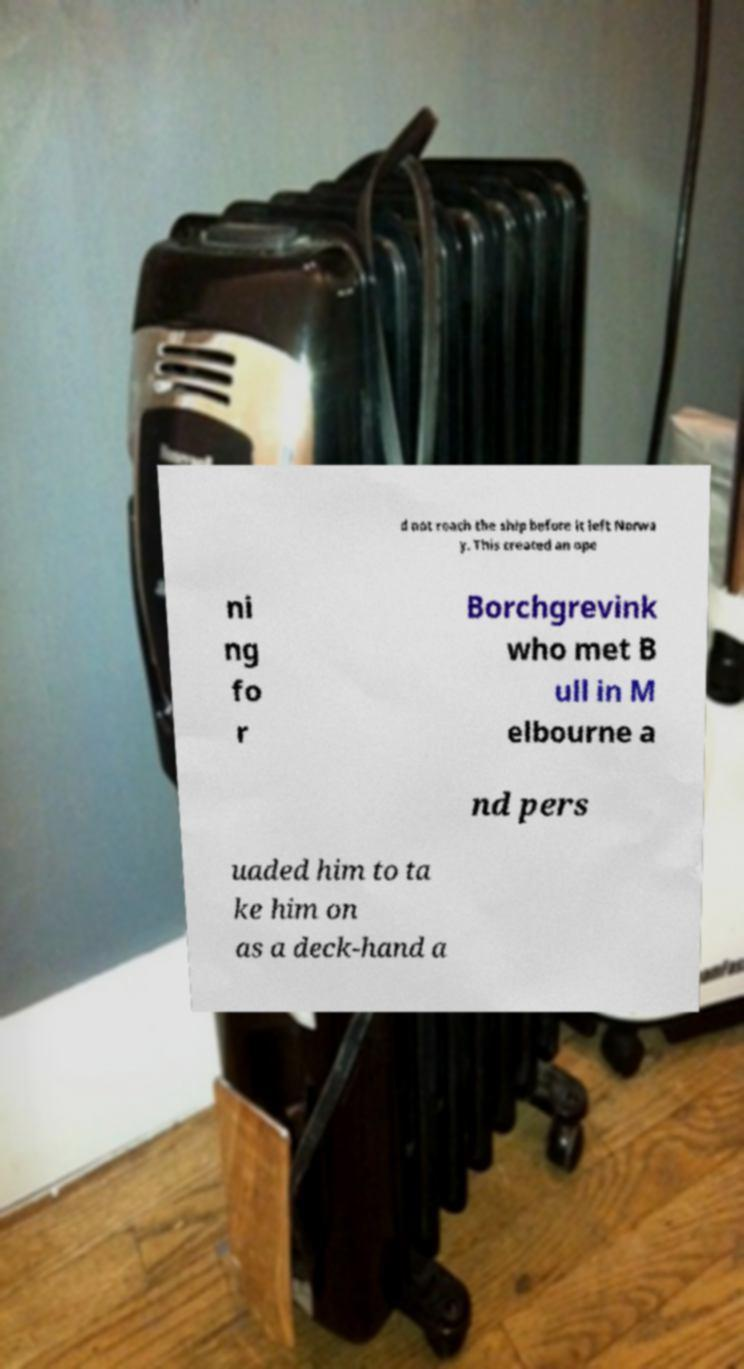I need the written content from this picture converted into text. Can you do that? d not reach the ship before it left Norwa y. This created an ope ni ng fo r Borchgrevink who met B ull in M elbourne a nd pers uaded him to ta ke him on as a deck-hand a 